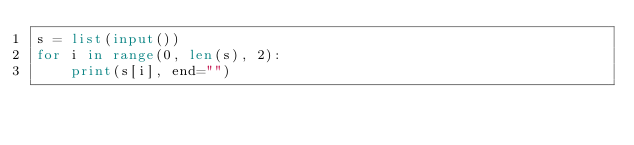Convert code to text. <code><loc_0><loc_0><loc_500><loc_500><_Python_>s = list(input())
for i in range(0, len(s), 2):
    print(s[i], end="")</code> 